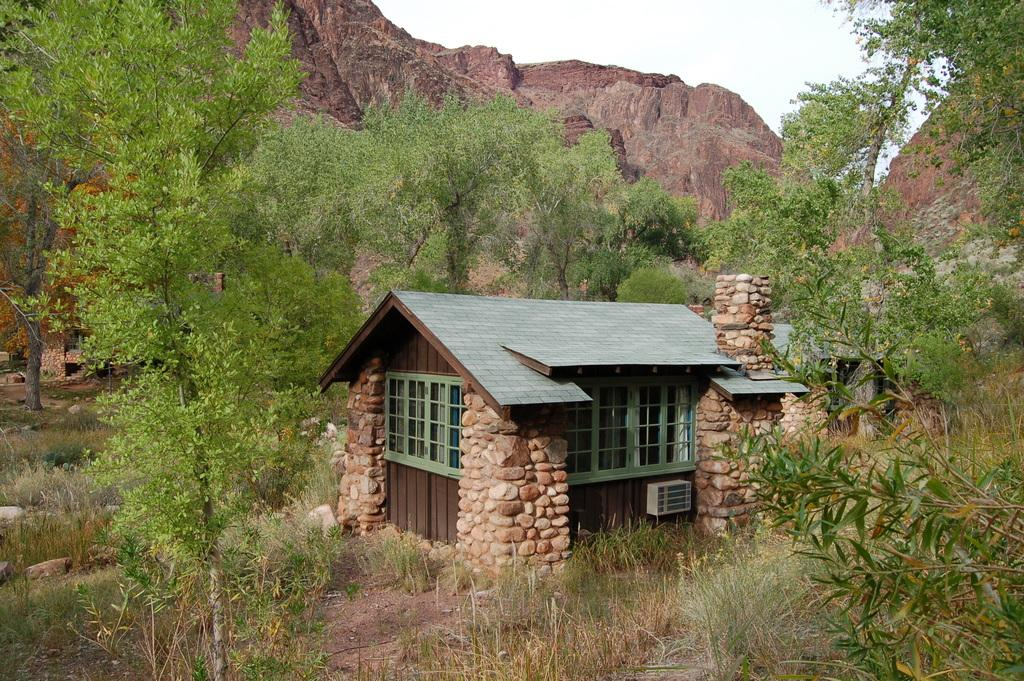What type of structure is present in the image? There is a house in the image. What type of vegetation can be seen in the image? There is grass and trees in the image. What type of natural landform is visible in the image? There are mountains in the image. What part of the natural environment is visible in the image? The sky is visible in the image. Based on the presence of the sky and the absence of artificial lighting, when do you think the image was taken? The image was likely taken during the day. How many marks are visible on the bird in the image? There is no bird present in the image, so it is not possible to determine the number of marks on a bird. 